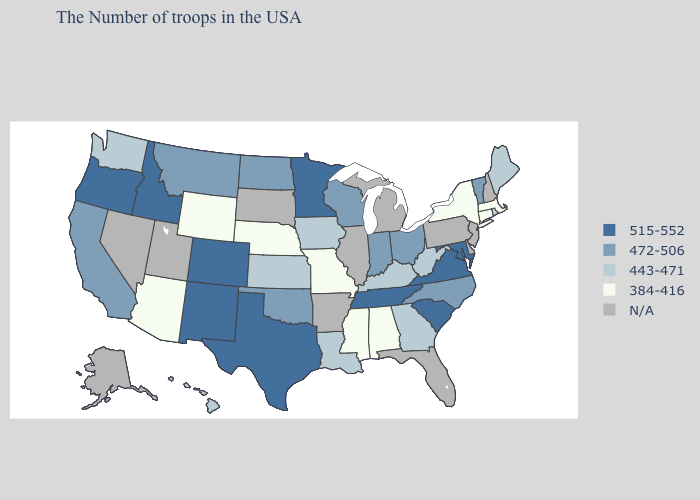Name the states that have a value in the range 515-552?
Give a very brief answer. Maryland, Virginia, South Carolina, Tennessee, Minnesota, Texas, Colorado, New Mexico, Idaho, Oregon. What is the lowest value in states that border Connecticut?
Concise answer only. 384-416. What is the lowest value in the USA?
Write a very short answer. 384-416. Name the states that have a value in the range 515-552?
Quick response, please. Maryland, Virginia, South Carolina, Tennessee, Minnesota, Texas, Colorado, New Mexico, Idaho, Oregon. What is the value of Wyoming?
Concise answer only. 384-416. What is the lowest value in the USA?
Concise answer only. 384-416. What is the value of Illinois?
Keep it brief. N/A. Name the states that have a value in the range 472-506?
Short answer required. Vermont, North Carolina, Ohio, Indiana, Wisconsin, Oklahoma, North Dakota, Montana, California. What is the highest value in the USA?
Give a very brief answer. 515-552. Among the states that border Texas , which have the lowest value?
Keep it brief. Louisiana. Name the states that have a value in the range 443-471?
Write a very short answer. Maine, Rhode Island, West Virginia, Georgia, Kentucky, Louisiana, Iowa, Kansas, Washington, Hawaii. What is the value of Texas?
Keep it brief. 515-552. Does New York have the lowest value in the Northeast?
Write a very short answer. Yes. What is the highest value in the USA?
Keep it brief. 515-552. Among the states that border Utah , which have the highest value?
Concise answer only. Colorado, New Mexico, Idaho. 